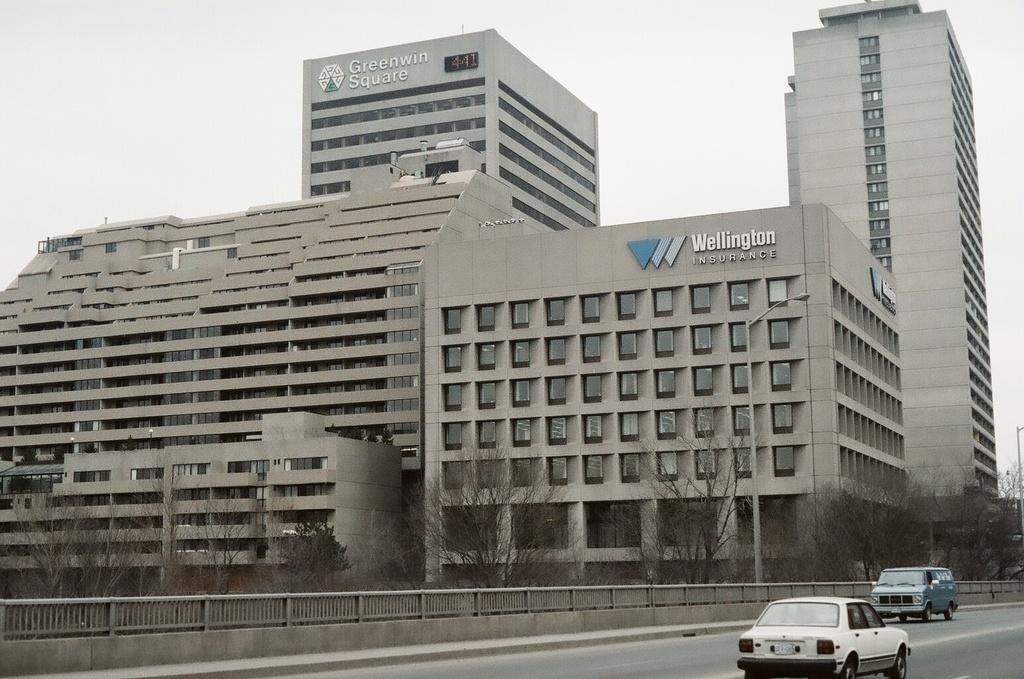How would you summarize this image in a sentence or two? In this picture we can see few buildings, trees and fence, and also we can find few cars on the road. 